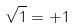Convert formula to latex. <formula><loc_0><loc_0><loc_500><loc_500>\sqrt { 1 } = + 1</formula> 